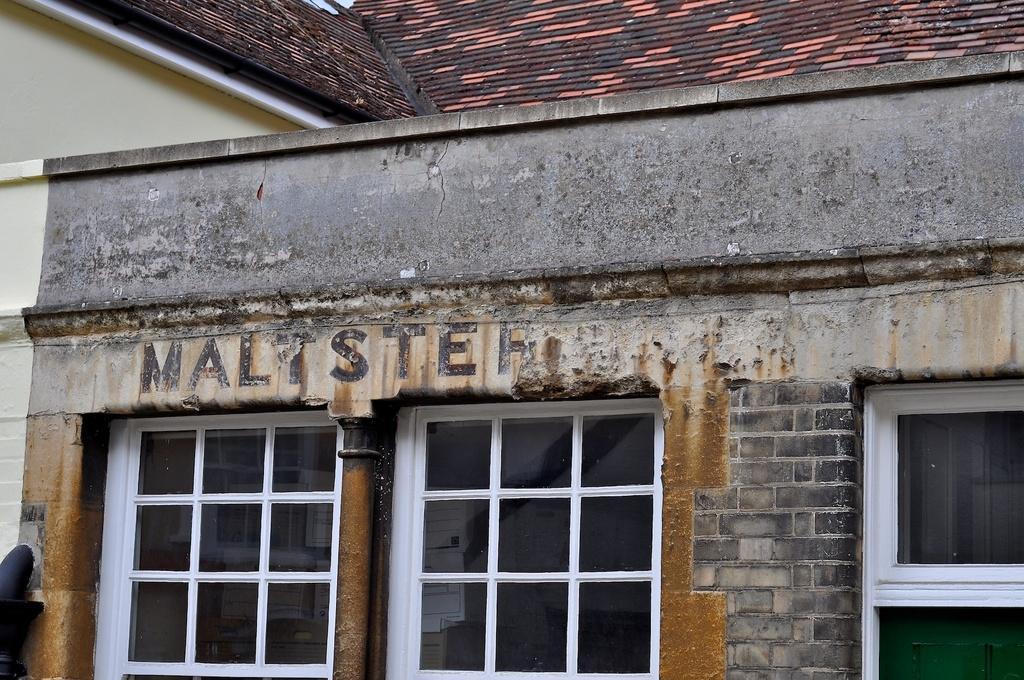Please provide a concise description of this image. In this image I can see a building, few pipes, few windows and here I can see something is written. 